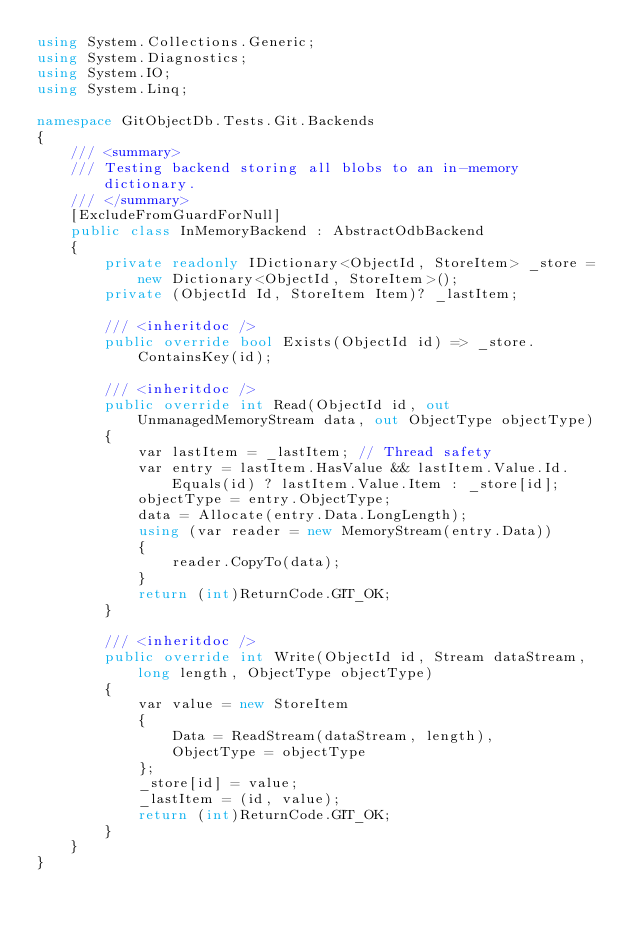<code> <loc_0><loc_0><loc_500><loc_500><_C#_>using System.Collections.Generic;
using System.Diagnostics;
using System.IO;
using System.Linq;

namespace GitObjectDb.Tests.Git.Backends
{
    /// <summary>
    /// Testing backend storing all blobs to an in-memory dictionary.
    /// </summary>
    [ExcludeFromGuardForNull]
    public class InMemoryBackend : AbstractOdbBackend
    {
        private readonly IDictionary<ObjectId, StoreItem> _store = new Dictionary<ObjectId, StoreItem>();
        private (ObjectId Id, StoreItem Item)? _lastItem;

        /// <inheritdoc />
        public override bool Exists(ObjectId id) => _store.ContainsKey(id);

        /// <inheritdoc />
        public override int Read(ObjectId id, out UnmanagedMemoryStream data, out ObjectType objectType)
        {
            var lastItem = _lastItem; // Thread safety
            var entry = lastItem.HasValue && lastItem.Value.Id.Equals(id) ? lastItem.Value.Item : _store[id];
            objectType = entry.ObjectType;
            data = Allocate(entry.Data.LongLength);
            using (var reader = new MemoryStream(entry.Data))
            {
                reader.CopyTo(data);
            }
            return (int)ReturnCode.GIT_OK;
        }

        /// <inheritdoc />
        public override int Write(ObjectId id, Stream dataStream, long length, ObjectType objectType)
        {
            var value = new StoreItem
            {
                Data = ReadStream(dataStream, length),
                ObjectType = objectType
            };
            _store[id] = value;
            _lastItem = (id, value);
            return (int)ReturnCode.GIT_OK;
        }
    }
}</code> 